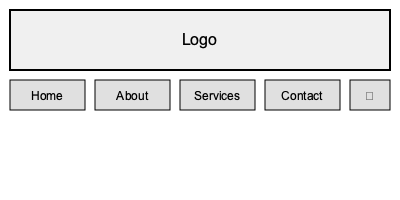Which arrangement of navigation elements in the website header shown above is most efficient for user experience and follows best practices in UI design? To determine the most efficient arrangement of navigation elements, we need to consider several factors:

1. Logo placement: The logo is correctly placed in the top-left corner, which is a standard practice for brand recognition and easy navigation back to the homepage.

2. Navigation menu: The main navigation items (Home, About, Services, Contact) are horizontally aligned below the logo, which is a common and user-friendly layout.

3. Order of items: The items are arranged in a logical order, starting with "Home" and ending with "Contact," which follows a natural progression of user needs.

4. Spacing: The navigation items are evenly spaced, making it easy for users to distinguish between them.

5. Hamburger menu: The hamburger menu (☰) is placed at the far right, which is a standard location for mobile-responsive designs.

6. Simplicity: The layout is clean and uncluttered, with only essential elements included.

7. Hierarchy: The logo is given prominence by its size and position, while the navigation items are secondary but easily accessible.

8. Consistency: All navigation items are styled consistently, improving readability and usability.

This arrangement follows best practices in UI design by:

- Placing the most important elements (logo and main navigation) in easily accessible locations
- Using a logical order for navigation items
- Providing a clear visual hierarchy
- Maintaining consistency in design
- Including a hamburger menu for responsive design

The layout is efficient because it allows users to quickly identify the brand, access key pages, and navigate the site with minimal cognitive load.
Answer: Current layout is optimal 